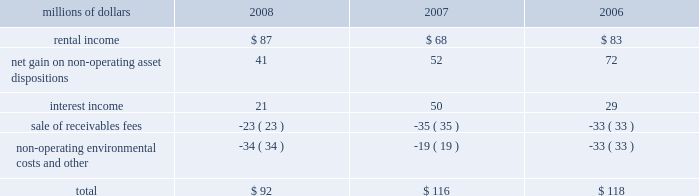The pension plan investments are held in a master trust , with the northern trust company .
Investments in the master trust are valued at fair value , which has been determined based on fair value of the underlying investments of the master trust .
Investments in securities traded on public security exchanges are valued at their closing market prices on the valuation date ; where no sale was made on the valuation date , the security is generally valued at its most recent bid price .
Certain short-term investments are carried at cost , which approximates fair value .
Investments in registered investment companies and common trust funds , which primarily invest in stocks , bonds , and commodity futures , are valued using publicly available market prices for the underlying investments held by these entities .
The majority of pension plan assets are invested in equity securities , because equity portfolios have historically provided higher returns than debt and other asset classes over extended time horizons , and are expected to do so in the future .
Correspondingly , equity investments also entail greater risks than other investments .
Equity risks are balanced by investing a significant portion of the plan 2019s assets in high quality debt securities .
The average quality rating of the debt portfolio exceeded aa as of december 31 , 2008 and 2007 .
The debt portfolio is also broadly diversified and invested primarily in u.s .
Treasury , mortgage , and corporate securities with an intermediate average maturity .
The weighted-average maturity of the debt portfolio was 5 years at both december 31 , 2008 and 2007 , respectively .
The investment of pension plan assets in securities issued by union pacific is specifically prohibited for both the equity and debt portfolios , other than through index fund holdings .
Other retirement programs thrift plan 2013 we provide a defined contribution plan ( thrift plan ) to eligible non-union employees and make matching contributions to the thrift plan .
We match 50 cents for each dollar contributed by employees up to the first six percent of compensation contributed .
Our thrift plan contributions were $ 14 million in 2008 , $ 14 million in 2007 , and $ 13 million in 2006 .
Railroad retirement system 2013 all railroad employees are covered by the railroad retirement system ( the system ) .
Contributions made to the system are expensed as incurred and amounted to approximately $ 620 million in 2008 , $ 616 million in 2007 , and $ 615 million in 2006 .
Collective bargaining agreements 2013 under collective bargaining agreements , we provide certain postretirement healthcare and life insurance benefits for eligible union employees .
Premiums under the plans are expensed as incurred and amounted to $ 49 million in 2008 and $ 40 million in both 2007 and 5 .
Other income other income included the following for the years ended december 31 : millions of dollars 2008 2007 2006 .

In 2008 what was the percentage of the total other income attributable to non-operating environmental costs? 
Computations: (34 / (21 + (87 + 41)))
Answer: 0.22819. The pension plan investments are held in a master trust , with the northern trust company .
Investments in the master trust are valued at fair value , which has been determined based on fair value of the underlying investments of the master trust .
Investments in securities traded on public security exchanges are valued at their closing market prices on the valuation date ; where no sale was made on the valuation date , the security is generally valued at its most recent bid price .
Certain short-term investments are carried at cost , which approximates fair value .
Investments in registered investment companies and common trust funds , which primarily invest in stocks , bonds , and commodity futures , are valued using publicly available market prices for the underlying investments held by these entities .
The majority of pension plan assets are invested in equity securities , because equity portfolios have historically provided higher returns than debt and other asset classes over extended time horizons , and are expected to do so in the future .
Correspondingly , equity investments also entail greater risks than other investments .
Equity risks are balanced by investing a significant portion of the plan 2019s assets in high quality debt securities .
The average quality rating of the debt portfolio exceeded aa as of december 31 , 2008 and 2007 .
The debt portfolio is also broadly diversified and invested primarily in u.s .
Treasury , mortgage , and corporate securities with an intermediate average maturity .
The weighted-average maturity of the debt portfolio was 5 years at both december 31 , 2008 and 2007 , respectively .
The investment of pension plan assets in securities issued by union pacific is specifically prohibited for both the equity and debt portfolios , other than through index fund holdings .
Other retirement programs thrift plan 2013 we provide a defined contribution plan ( thrift plan ) to eligible non-union employees and make matching contributions to the thrift plan .
We match 50 cents for each dollar contributed by employees up to the first six percent of compensation contributed .
Our thrift plan contributions were $ 14 million in 2008 , $ 14 million in 2007 , and $ 13 million in 2006 .
Railroad retirement system 2013 all railroad employees are covered by the railroad retirement system ( the system ) .
Contributions made to the system are expensed as incurred and amounted to approximately $ 620 million in 2008 , $ 616 million in 2007 , and $ 615 million in 2006 .
Collective bargaining agreements 2013 under collective bargaining agreements , we provide certain postretirement healthcare and life insurance benefits for eligible union employees .
Premiums under the plans are expensed as incurred and amounted to $ 49 million in 2008 and $ 40 million in both 2007 and 5 .
Other income other income included the following for the years ended december 31 : millions of dollars 2008 2007 2006 .

What was the average thrift plan contribution from 2006 to 2008 in millions? 
Computations: (((14 + 14) + 13) / 3)
Answer: 13.66667. 